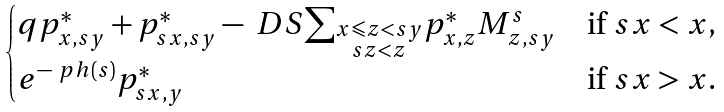<formula> <loc_0><loc_0><loc_500><loc_500>\begin{cases} q p _ { x , s y } ^ { * } + p _ { s x , s y } ^ { * } - \ D S { \sum _ { \substack { x \leqslant z < s y \\ s z < z } } } p _ { x , z } ^ { * } M _ { z , s y } ^ { s } & \text {if $sx < x$,} \\ e ^ { - \ p h ( s ) } p _ { s x , y } ^ { * } & \text {if $sx > x$.} \end{cases}</formula> 